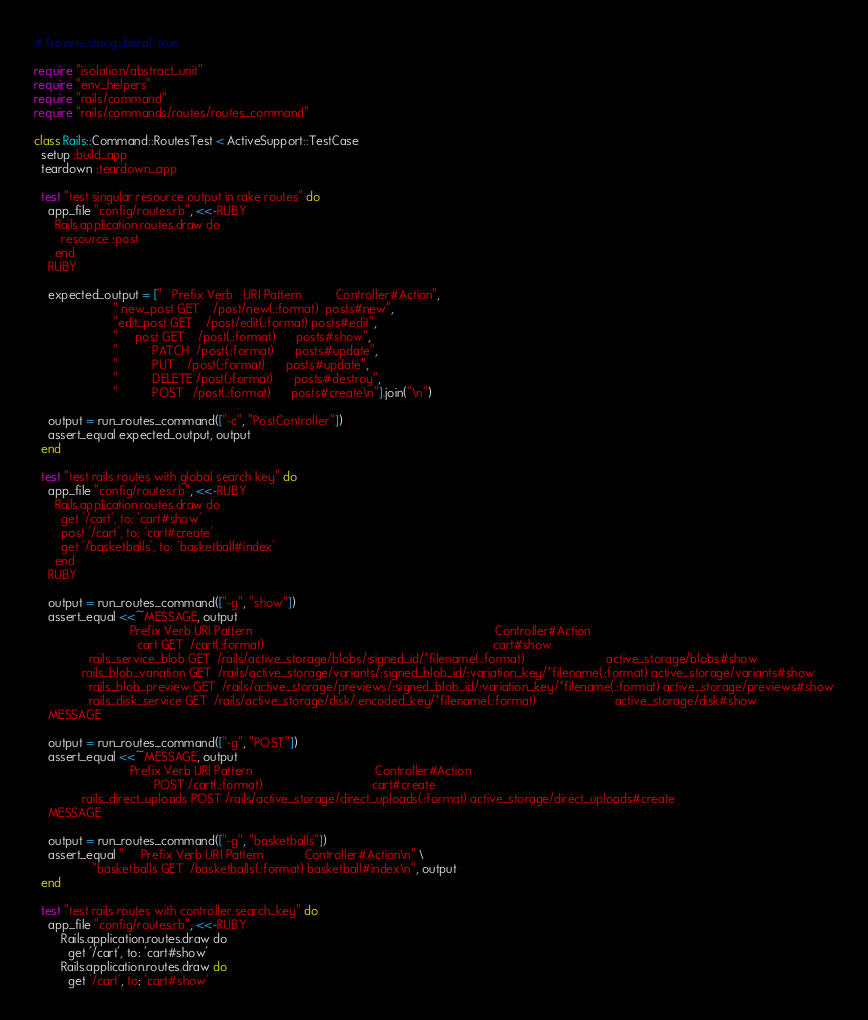<code> <loc_0><loc_0><loc_500><loc_500><_Ruby_># frozen_string_literal: true

require "isolation/abstract_unit"
require "env_helpers"
require "rails/command"
require "rails/commands/routes/routes_command"

class Rails::Command::RoutesTest < ActiveSupport::TestCase
  setup :build_app
  teardown :teardown_app

  test "test singular resource output in rake routes" do
    app_file "config/routes.rb", <<-RUBY
      Rails.application.routes.draw do
        resource :post
      end
    RUBY

    expected_output = ["   Prefix Verb   URI Pattern          Controller#Action",
                       " new_post GET    /post/new(.:format)  posts#new",
                       "edit_post GET    /post/edit(.:format) posts#edit",
                       "     post GET    /post(.:format)      posts#show",
                       "          PATCH  /post(.:format)      posts#update",
                       "          PUT    /post(.:format)      posts#update",
                       "          DELETE /post(.:format)      posts#destroy",
                       "          POST   /post(.:format)      posts#create\n"].join("\n")

    output = run_routes_command(["-c", "PostController"])
    assert_equal expected_output, output
  end

  test "test rails routes with global search key" do
    app_file "config/routes.rb", <<-RUBY
      Rails.application.routes.draw do
        get '/cart', to: 'cart#show'
        post '/cart', to: 'cart#create'
        get '/basketballs', to: 'basketball#index'
      end
    RUBY

    output = run_routes_command(["-g", "show"])
    assert_equal <<~MESSAGE, output
                            Prefix Verb URI Pattern                                                                       Controller#Action
                              cart GET  /cart(.:format)                                                                   cart#show
                rails_service_blob GET  /rails/active_storage/blobs/:signed_id/*filename(.:format)                        active_storage/blobs#show
              rails_blob_variation GET  /rails/active_storage/variants/:signed_blob_id/:variation_key/*filename(.:format) active_storage/variants#show
                rails_blob_preview GET  /rails/active_storage/previews/:signed_blob_id/:variation_key/*filename(.:format) active_storage/previews#show
                rails_disk_service GET  /rails/active_storage/disk/:encoded_key/*filename(.:format)                       active_storage/disk#show
    MESSAGE

    output = run_routes_command(["-g", "POST"])
    assert_equal <<~MESSAGE, output
                            Prefix Verb URI Pattern                                    Controller#Action
                                   POST /cart(.:format)                                cart#create
              rails_direct_uploads POST /rails/active_storage/direct_uploads(.:format) active_storage/direct_uploads#create
    MESSAGE

    output = run_routes_command(["-g", "basketballs"])
    assert_equal "     Prefix Verb URI Pattern            Controller#Action\n" \
                 "basketballs GET  /basketballs(.:format) basketball#index\n", output
  end

  test "test rails routes with controller search_key" do
    app_file "config/routes.rb", <<-RUBY
        Rails.application.routes.draw do
          get '/cart', to: 'cart#show'</code> 